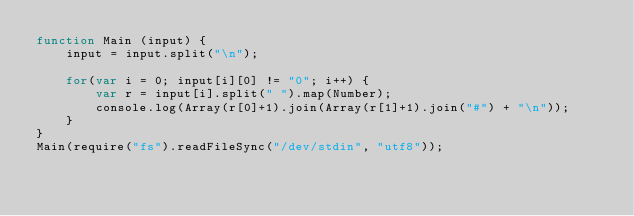Convert code to text. <code><loc_0><loc_0><loc_500><loc_500><_JavaScript_>function Main (input) {
    input = input.split("\n");

    for(var i = 0; input[i][0] != "0"; i++) {
        var r = input[i].split(" ").map(Number);
        console.log(Array(r[0]+1).join(Array(r[1]+1).join("#") + "\n"));
    }
}
Main(require("fs").readFileSync("/dev/stdin", "utf8"));</code> 